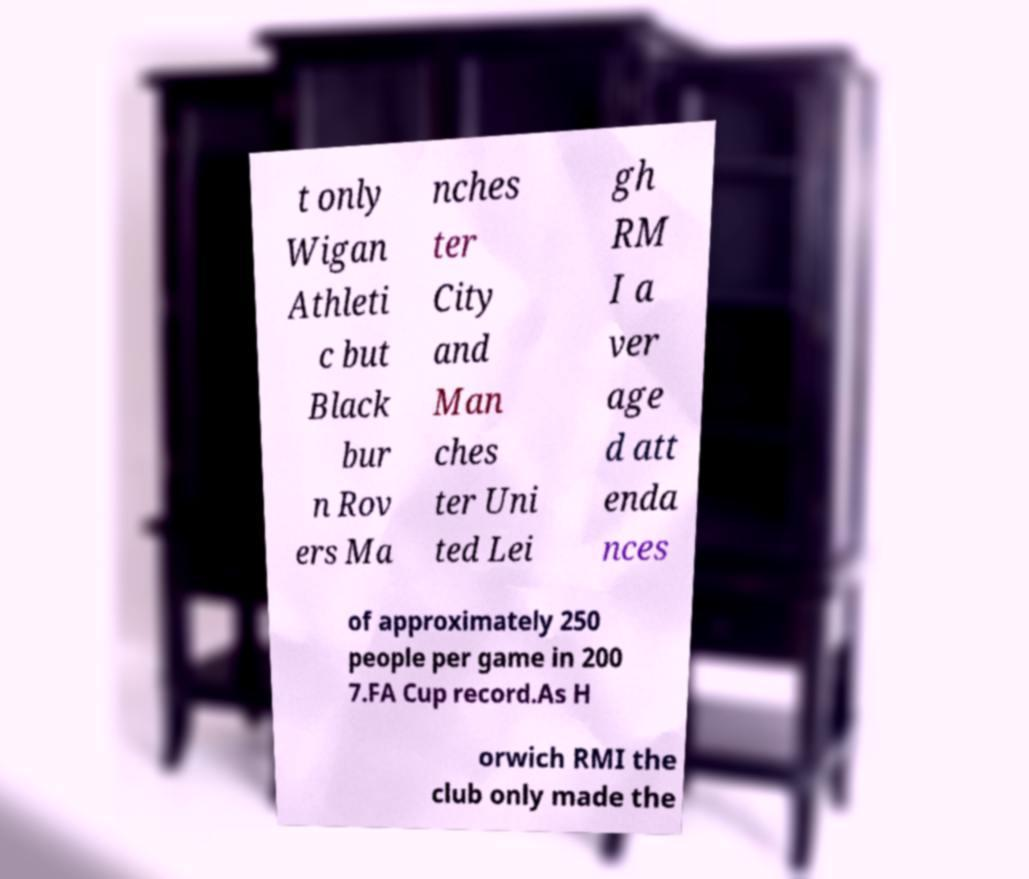Can you read and provide the text displayed in the image?This photo seems to have some interesting text. Can you extract and type it out for me? t only Wigan Athleti c but Black bur n Rov ers Ma nches ter City and Man ches ter Uni ted Lei gh RM I a ver age d att enda nces of approximately 250 people per game in 200 7.FA Cup record.As H orwich RMI the club only made the 